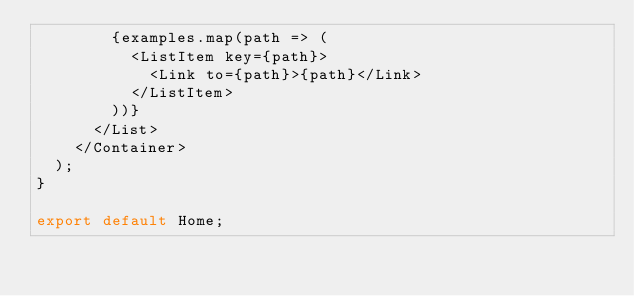<code> <loc_0><loc_0><loc_500><loc_500><_JavaScript_>        {examples.map(path => (
          <ListItem key={path}>
            <Link to={path}>{path}</Link>
          </ListItem>
        ))}
      </List>
    </Container>
  );
}

export default Home;
</code> 